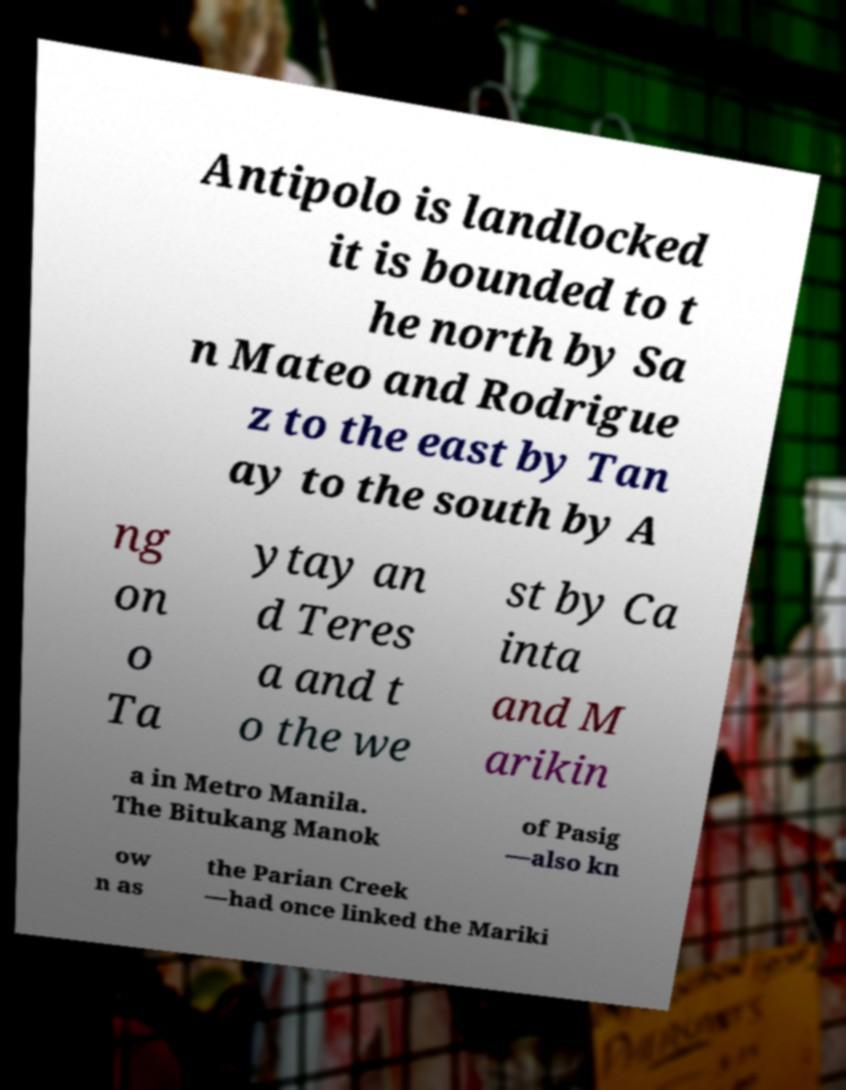Could you assist in decoding the text presented in this image and type it out clearly? Antipolo is landlocked it is bounded to t he north by Sa n Mateo and Rodrigue z to the east by Tan ay to the south by A ng on o Ta ytay an d Teres a and t o the we st by Ca inta and M arikin a in Metro Manila. The Bitukang Manok of Pasig —also kn ow n as the Parian Creek —had once linked the Mariki 